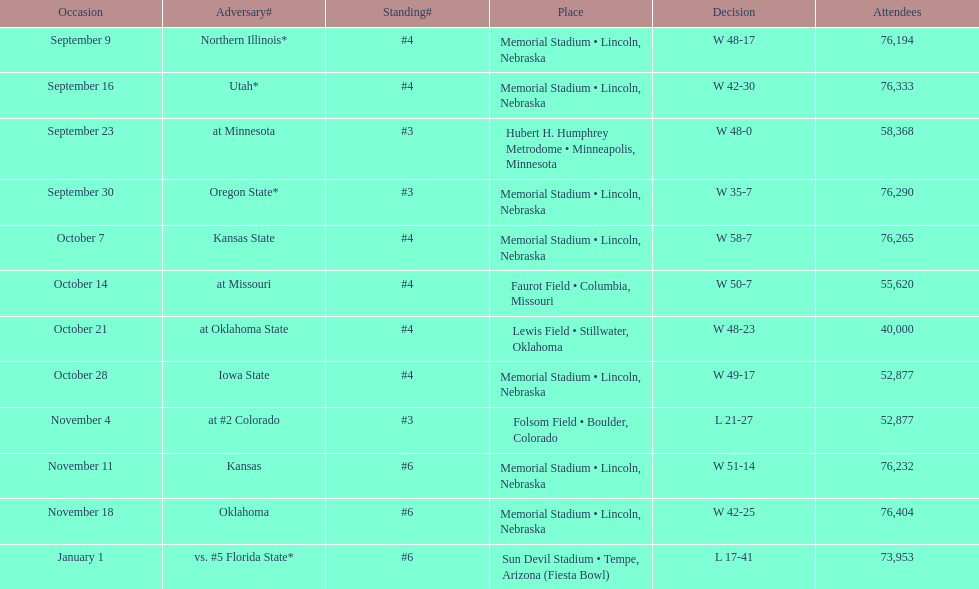What site at most is taken place? Memorial Stadium • Lincoln, Nebraska. 